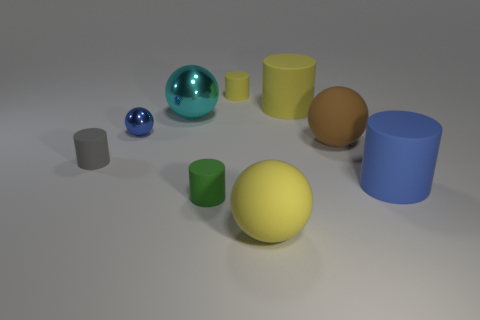Subtract all blue cylinders. How many cylinders are left? 4 Subtract all small gray matte cylinders. How many cylinders are left? 4 Subtract 2 spheres. How many spheres are left? 2 Subtract all purple spheres. Subtract all green cylinders. How many spheres are left? 4 Subtract all cylinders. How many objects are left? 4 Subtract 1 blue cylinders. How many objects are left? 8 Subtract all big gray metallic objects. Subtract all small gray matte cylinders. How many objects are left? 8 Add 9 big cyan shiny spheres. How many big cyan shiny spheres are left? 10 Add 2 large purple things. How many large purple things exist? 2 